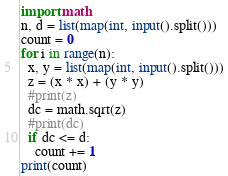Convert code to text. <code><loc_0><loc_0><loc_500><loc_500><_Python_>import math
n, d = list(map(int, input().split()))
count = 0
for i in range(n):
  x, y = list(map(int, input().split()))
  z = (x * x) + (y * y)
  #print(z)
  dc = math.sqrt(z)
  #print(dc)
  if dc <= d:
    count += 1
print(count)</code> 